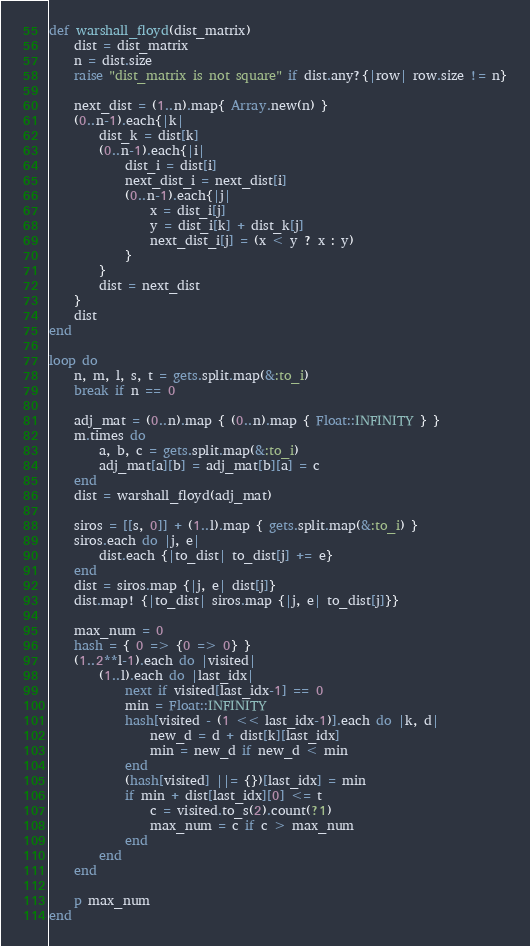<code> <loc_0><loc_0><loc_500><loc_500><_Ruby_>def warshall_floyd(dist_matrix)
	dist = dist_matrix
	n = dist.size
	raise "dist_matrix is not square" if dist.any?{|row| row.size != n}

	next_dist = (1..n).map{ Array.new(n) }	
	(0..n-1).each{|k|
		dist_k = dist[k]
		(0..n-1).each{|i|
			dist_i = dist[i]
			next_dist_i = next_dist[i]
			(0..n-1).each{|j|
				x = dist_i[j]
				y = dist_i[k] + dist_k[j]
				next_dist_i[j] = (x < y ? x : y)
			}
		}
		dist = next_dist
	}
	dist
end

loop do
	n, m, l, s, t = gets.split.map(&:to_i)
	break if n == 0

	adj_mat = (0..n).map { (0..n).map { Float::INFINITY } }
	m.times do
		a, b, c = gets.split.map(&:to_i)
		adj_mat[a][b] = adj_mat[b][a] = c
	end
	dist = warshall_floyd(adj_mat)

	siros = [[s, 0]] + (1..l).map { gets.split.map(&:to_i) }
	siros.each do |j, e|
		dist.each {|to_dist| to_dist[j] += e}
	end
	dist = siros.map {|j, e| dist[j]}
	dist.map! {|to_dist| siros.map {|j, e| to_dist[j]}}

	max_num = 0
	hash = { 0 => {0 => 0} }
	(1..2**l-1).each do |visited|
		(1..l).each do |last_idx|
			next if visited[last_idx-1] == 0
			min = Float::INFINITY
			hash[visited - (1 << last_idx-1)].each do |k, d|
				new_d = d + dist[k][last_idx]
				min = new_d if new_d < min
			end
			(hash[visited] ||= {})[last_idx] = min
			if min + dist[last_idx][0] <= t
				c = visited.to_s(2).count(?1)
				max_num = c if c > max_num
			end
		end
	end

	p max_num
end</code> 